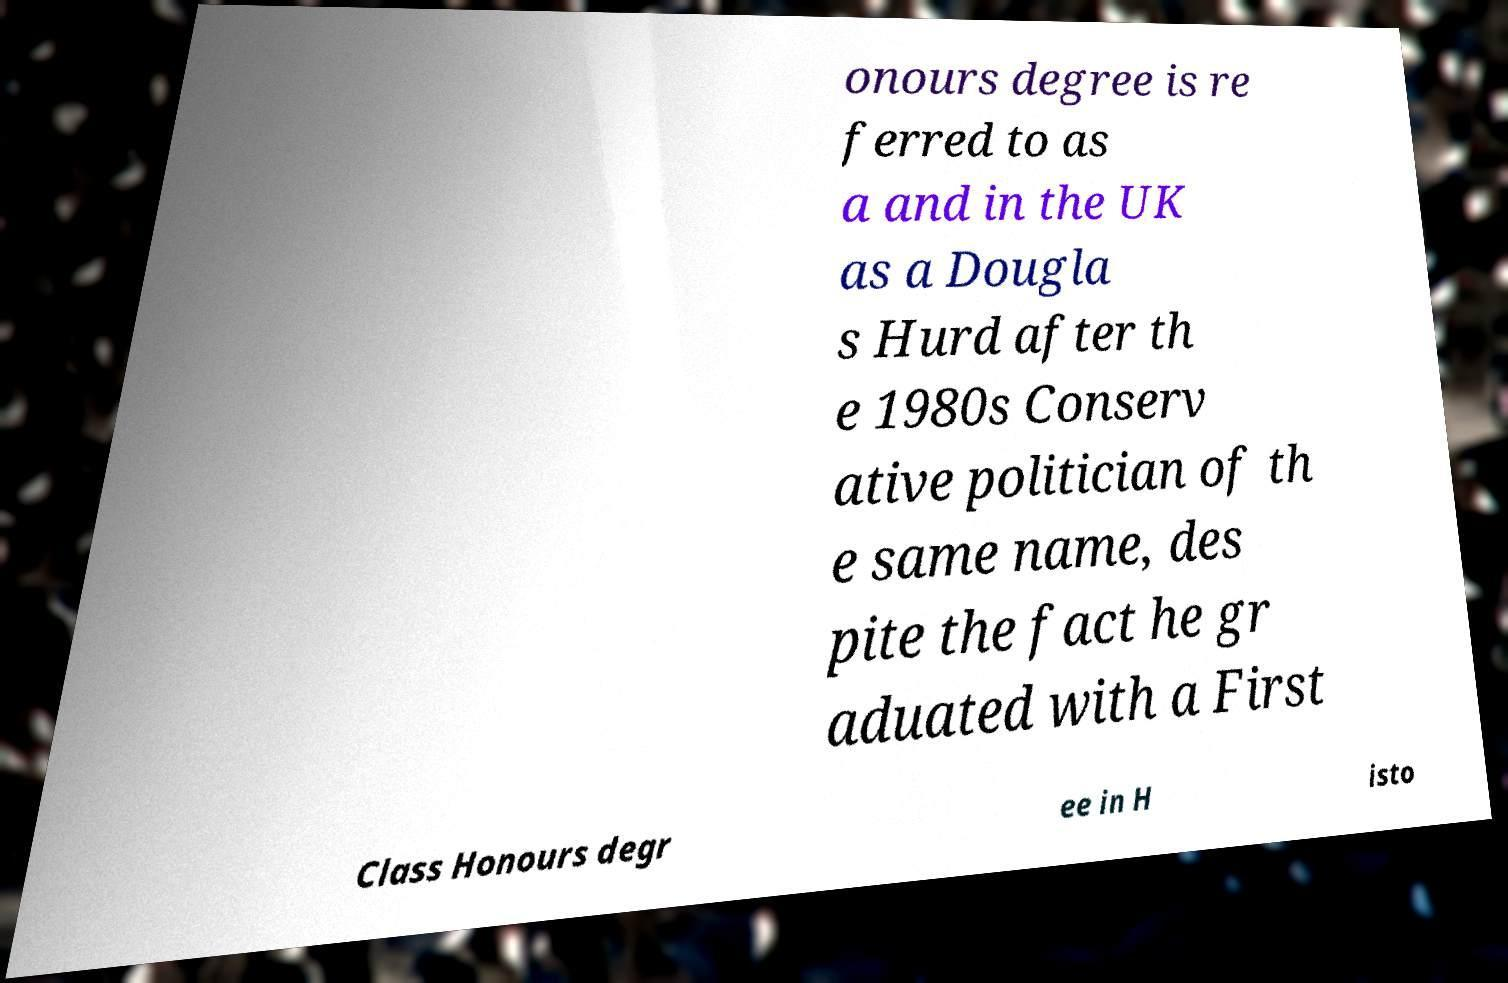What messages or text are displayed in this image? I need them in a readable, typed format. onours degree is re ferred to as a and in the UK as a Dougla s Hurd after th e 1980s Conserv ative politician of th e same name, des pite the fact he gr aduated with a First Class Honours degr ee in H isto 